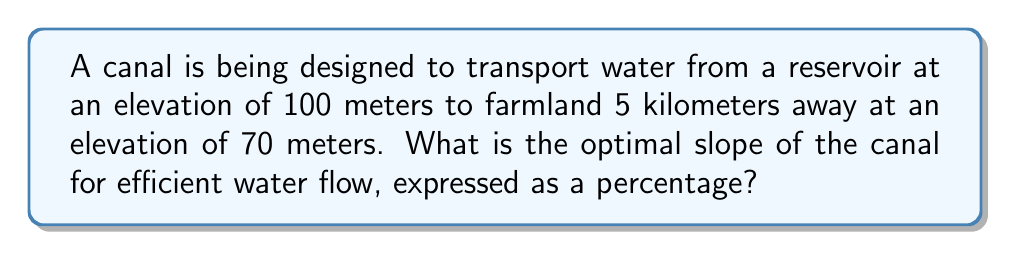Help me with this question. To determine the slope of the canal, we need to follow these steps:

1. Calculate the change in elevation:
   $\Delta y = 100\text{ m} - 70\text{ m} = 30\text{ m}$

2. Convert the horizontal distance to meters:
   $\Delta x = 5\text{ km} = 5000\text{ m}$

3. Calculate the slope using the formula:
   $\text{Slope} = \frac{\text{Rise}}{\text{Run}} = \frac{\Delta y}{\Delta x}$

   $$\text{Slope} = \frac{30\text{ m}}{5000\text{ m}} = 0.006$$

4. Convert the slope to a percentage:
   $$\text{Slope percentage} = \text{Slope} \times 100\% = 0.006 \times 100\% = 0.6\%$$

The optimal slope for efficient water flow in canals is typically between 0.5% and 1%. Our calculated slope of 0.6% falls within this range, making it suitable for optimal water flow.
Answer: 0.6% 